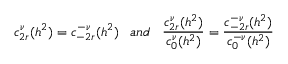Convert formula to latex. <formula><loc_0><loc_0><loc_500><loc_500>c _ { 2 r } ^ { \nu } ( h ^ { 2 } ) = c _ { - 2 r } ^ { - \nu } ( h ^ { 2 } ) \, a n d \, \frac { c _ { 2 r } ^ { \nu } ( h ^ { 2 } ) } { c _ { 0 } ^ { \nu } ( h ^ { 2 } ) } = \frac { c _ { - 2 r } ^ { - \nu } ( h ^ { 2 } ) } { c _ { 0 } ^ { - \nu } ( h ^ { 2 } ) }</formula> 